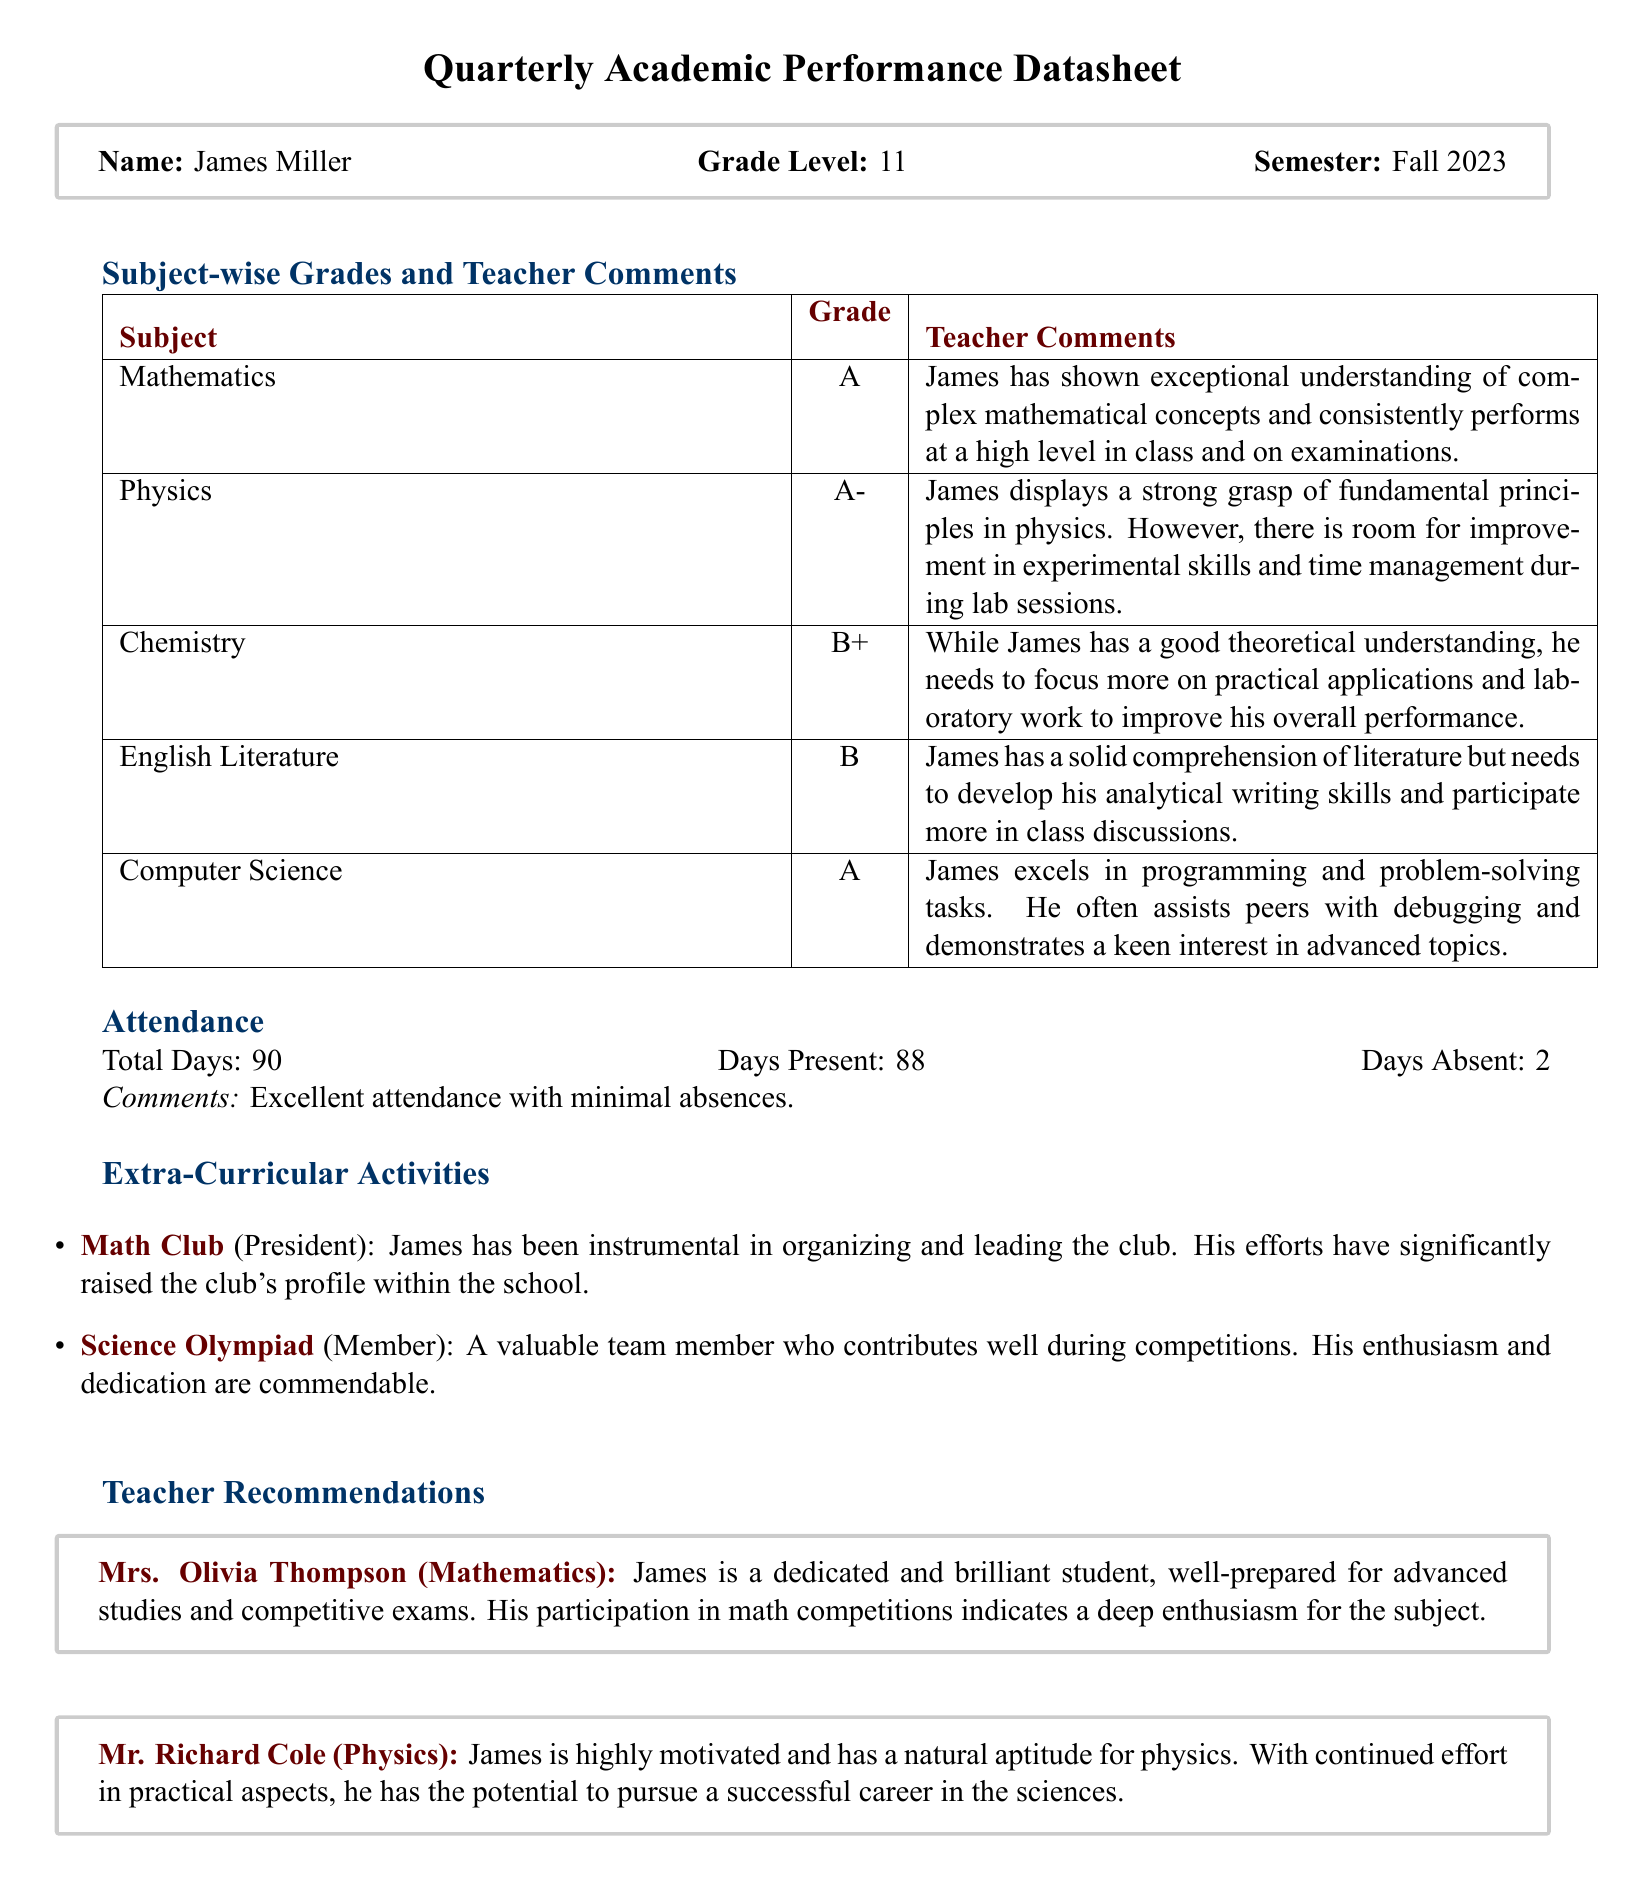What is James's grade in Mathematics? The grade for Mathematics is clearly stated in the document as "A".
Answer: A How many days was James absent? The datasheet mentions that James was absent for 2 days.
Answer: 2 Which subject has the lowest grade? By comparing the grades listed, Chemistry has the lowest grade of B+.
Answer: Chemistry Who is the teacher for Physics? The document identifies Mr. Richard Cole as the teacher for Physics.
Answer: Mr. Richard Cole What extracurricular activity is James the president of? According to the report, James is the president of the Math Club.
Answer: Math Club What is James's attendance percentage? The attendance percentage can be calculated from days present and total days: (88/90)*100 = 97.78%, which indicates excellent attendance.
Answer: 97.78% What does the teacher recommend for James in Physics? The teacher, Mr. Richard Cole, recommends that James should continue effort in practical aspects for success.
Answer: Continued effort in practical aspects Which subject does James excel in programming? The document states that James excels in Computer Science regarding programming skills.
Answer: Computer Science What role does James hold in the Science Olympiad? The report indicates that James is a member of the Science Olympiad team.
Answer: Member 